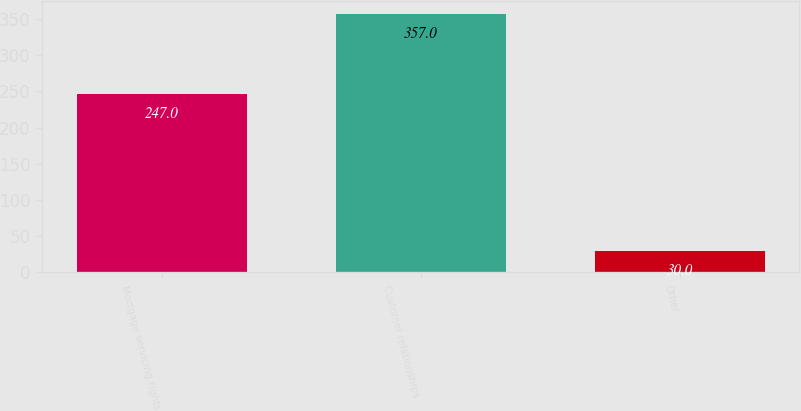Convert chart. <chart><loc_0><loc_0><loc_500><loc_500><bar_chart><fcel>Mortgage servicing rights<fcel>Customer relationships<fcel>Other<nl><fcel>247<fcel>357<fcel>30<nl></chart> 